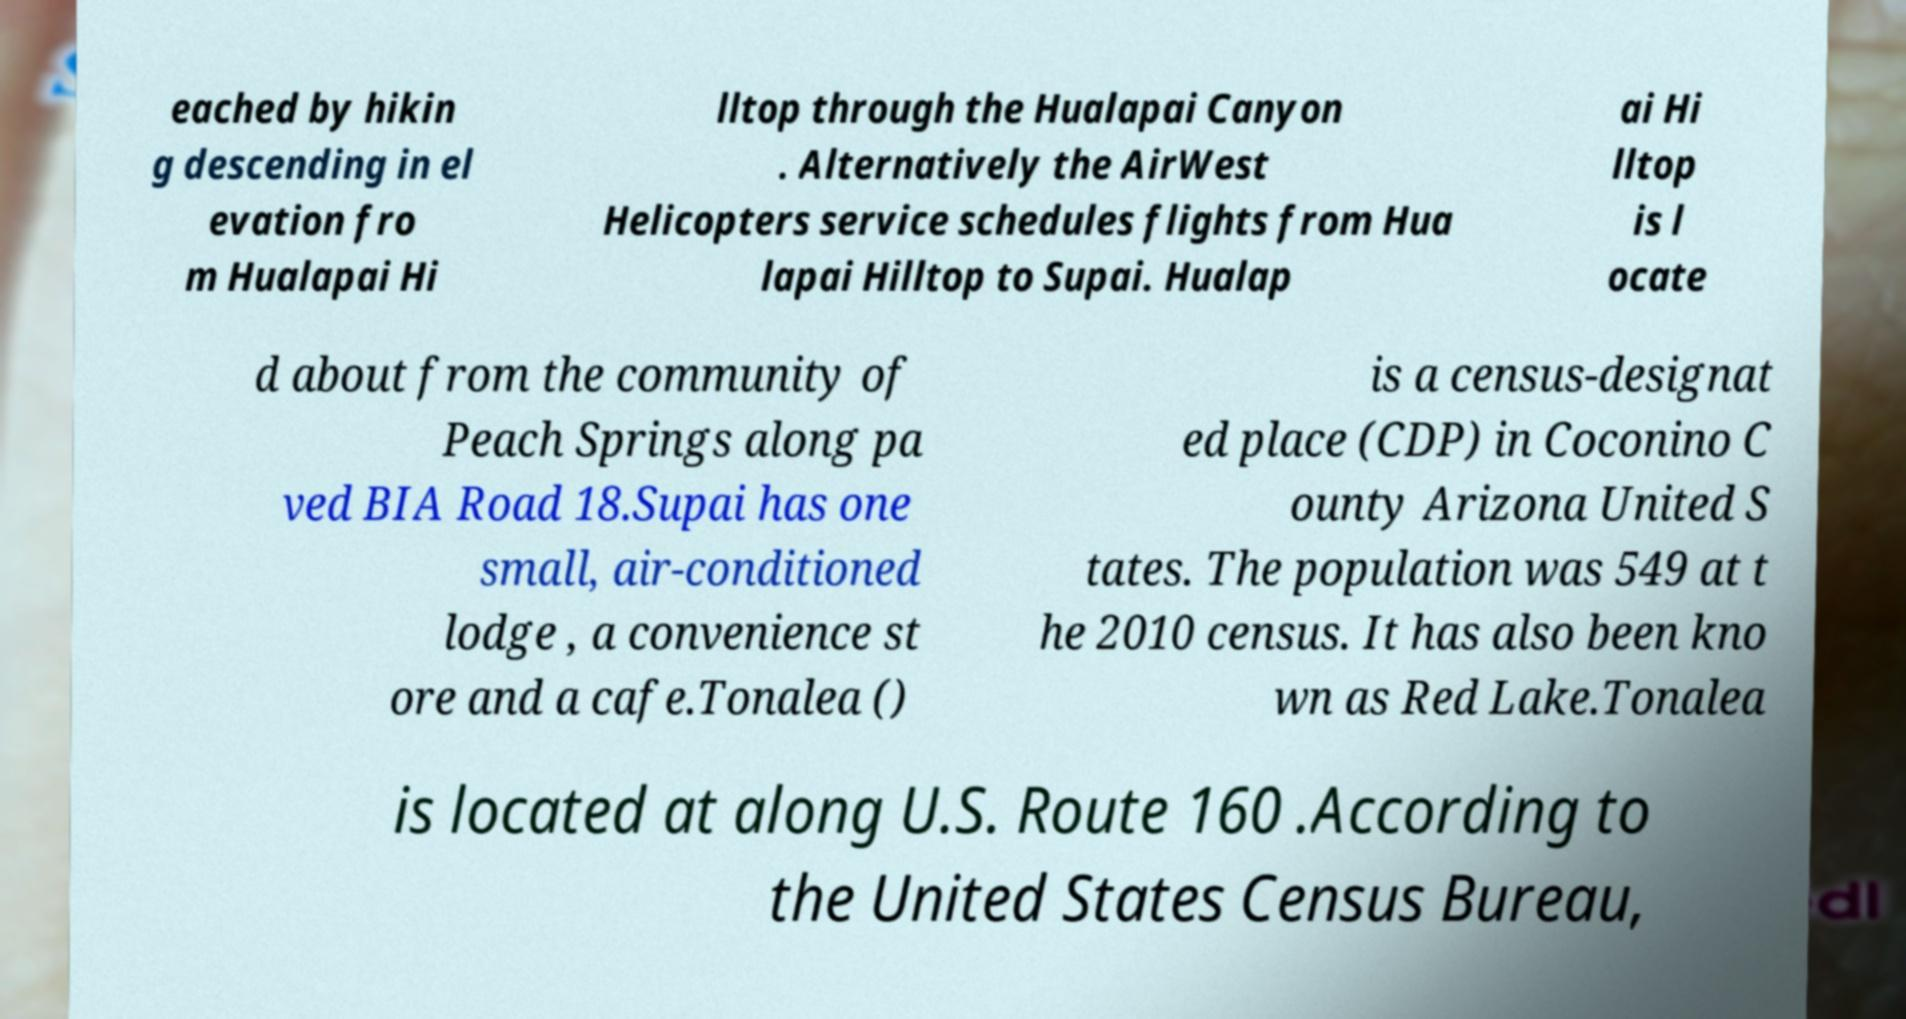What messages or text are displayed in this image? I need them in a readable, typed format. eached by hikin g descending in el evation fro m Hualapai Hi lltop through the Hualapai Canyon . Alternatively the AirWest Helicopters service schedules flights from Hua lapai Hilltop to Supai. Hualap ai Hi lltop is l ocate d about from the community of Peach Springs along pa ved BIA Road 18.Supai has one small, air-conditioned lodge , a convenience st ore and a cafe.Tonalea () is a census-designat ed place (CDP) in Coconino C ounty Arizona United S tates. The population was 549 at t he 2010 census. It has also been kno wn as Red Lake.Tonalea is located at along U.S. Route 160 .According to the United States Census Bureau, 